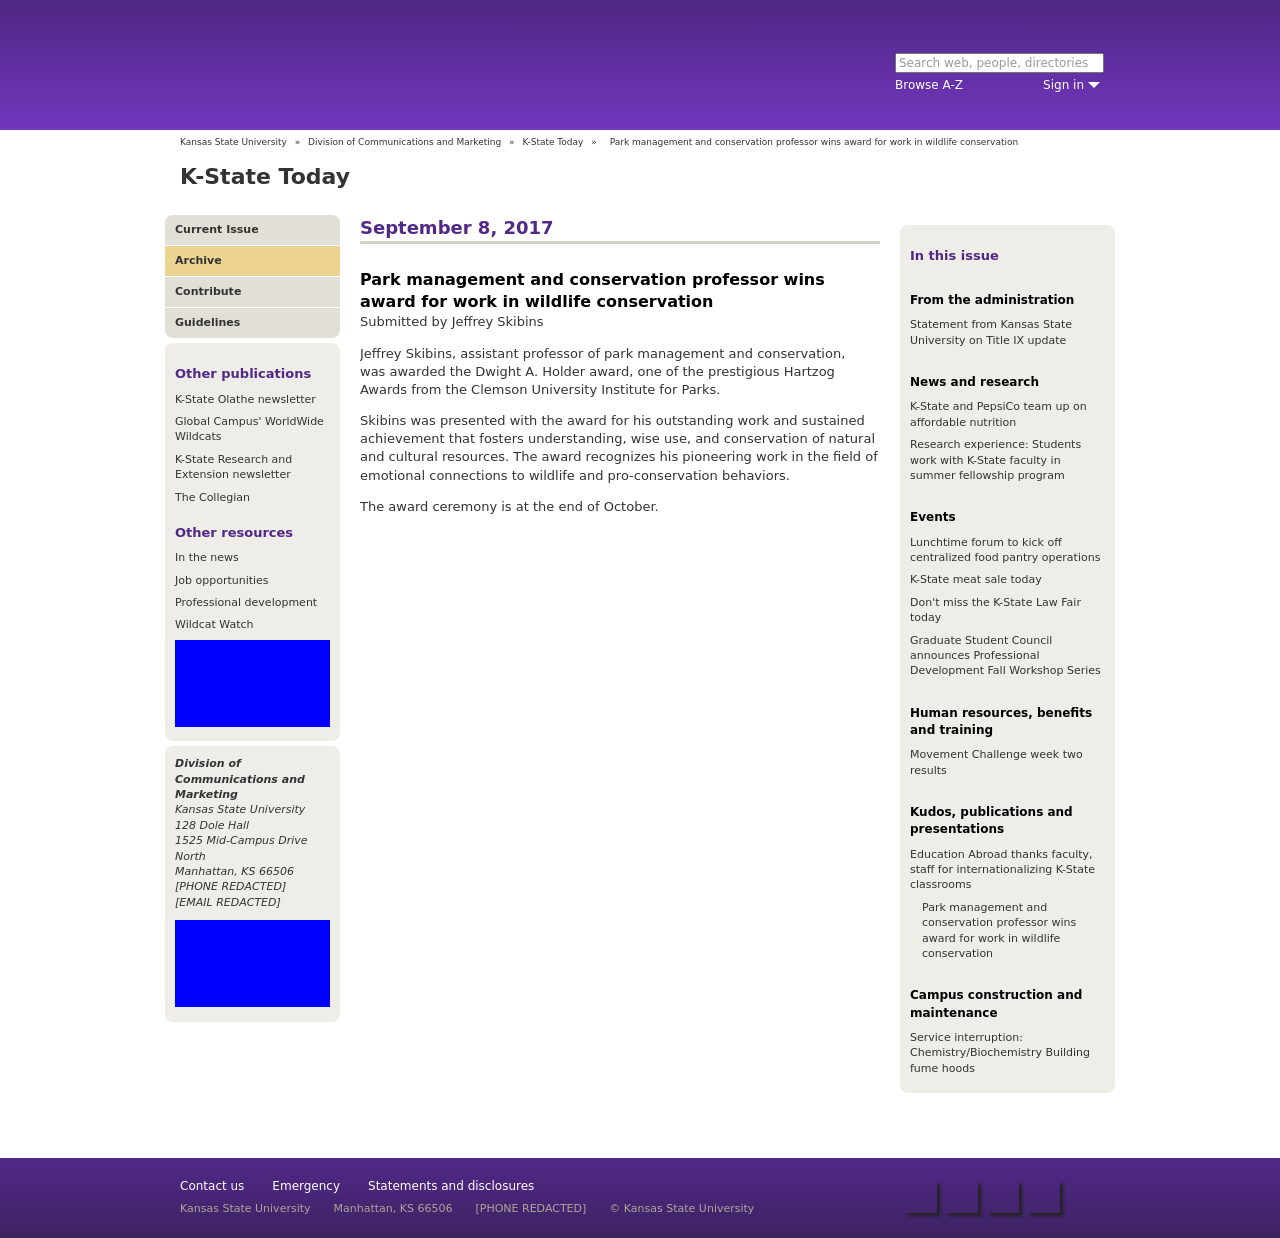How can I start building this website with HTML from the ground up? To start building a website with HTML from the ground up, begin by setting up the basic structure with HTML tags such as <!DOCTYPE html>, <html>, <head>, and <body>. Within the head section, include meta tags for setting character sets and responsive behavior, and incorporate CSS for styling within <style> tags. Ensure your site is ADA-compliant by including accessibility features and use media queries to make the site responsive. Write clear, semantic HTML and organize content effectively for scalability and maintenance. 